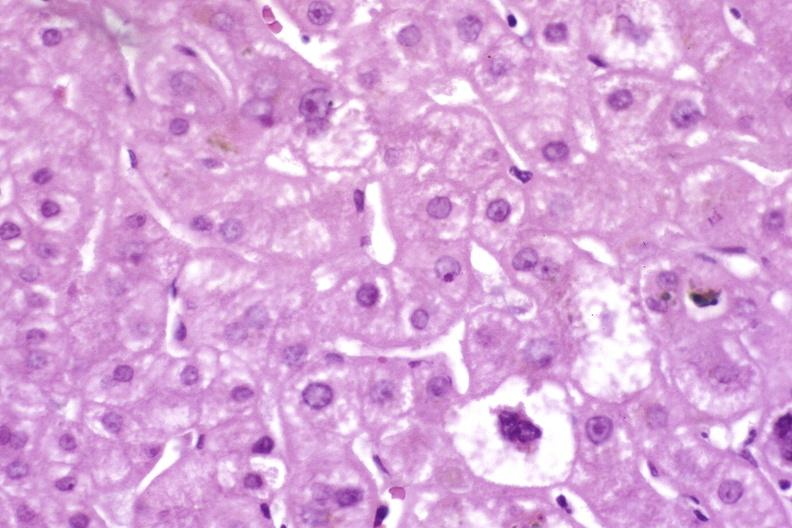s hepatobiliary present?
Answer the question using a single word or phrase. Yes 